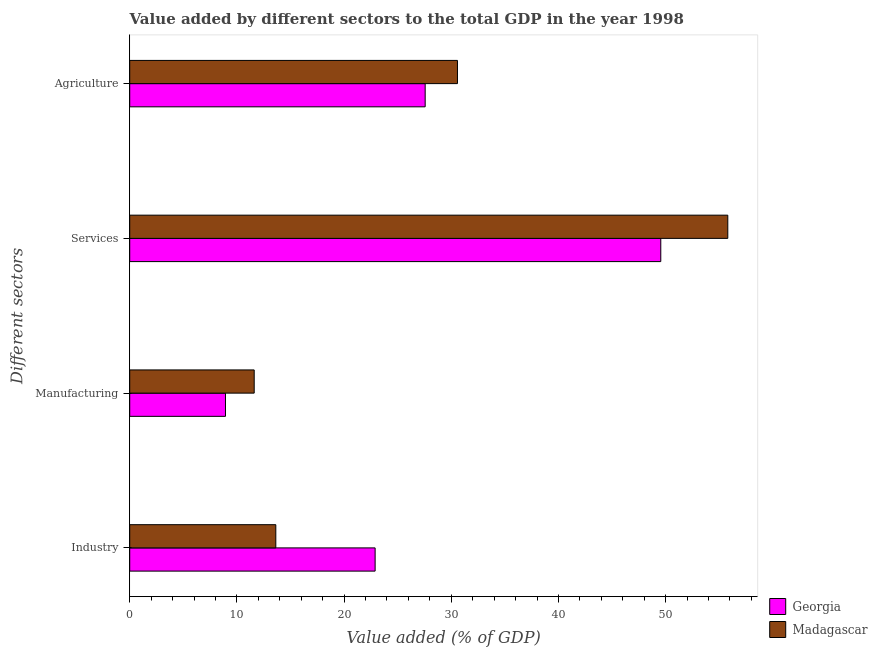How many groups of bars are there?
Offer a terse response. 4. How many bars are there on the 1st tick from the top?
Your response must be concise. 2. What is the label of the 1st group of bars from the top?
Ensure brevity in your answer.  Agriculture. What is the value added by agricultural sector in Georgia?
Offer a very short reply. 27.56. Across all countries, what is the maximum value added by industrial sector?
Make the answer very short. 22.89. Across all countries, what is the minimum value added by industrial sector?
Ensure brevity in your answer.  13.63. In which country was the value added by manufacturing sector maximum?
Your answer should be very brief. Madagascar. In which country was the value added by manufacturing sector minimum?
Provide a succinct answer. Georgia. What is the total value added by agricultural sector in the graph?
Make the answer very short. 58.14. What is the difference between the value added by services sector in Georgia and that in Madagascar?
Give a very brief answer. -6.25. What is the difference between the value added by agricultural sector in Madagascar and the value added by services sector in Georgia?
Your response must be concise. -18.97. What is the average value added by agricultural sector per country?
Provide a succinct answer. 29.07. What is the difference between the value added by services sector and value added by industrial sector in Madagascar?
Keep it short and to the point. 42.17. In how many countries, is the value added by industrial sector greater than 36 %?
Ensure brevity in your answer.  0. What is the ratio of the value added by manufacturing sector in Madagascar to that in Georgia?
Give a very brief answer. 1.3. What is the difference between the highest and the second highest value added by industrial sector?
Provide a succinct answer. 9.27. What is the difference between the highest and the lowest value added by services sector?
Ensure brevity in your answer.  6.25. What does the 1st bar from the top in Manufacturing represents?
Offer a terse response. Madagascar. What does the 2nd bar from the bottom in Services represents?
Keep it short and to the point. Madagascar. Is it the case that in every country, the sum of the value added by industrial sector and value added by manufacturing sector is greater than the value added by services sector?
Your answer should be compact. No. What is the difference between two consecutive major ticks on the X-axis?
Make the answer very short. 10. How many legend labels are there?
Your answer should be very brief. 2. What is the title of the graph?
Offer a terse response. Value added by different sectors to the total GDP in the year 1998. Does "Thailand" appear as one of the legend labels in the graph?
Your answer should be compact. No. What is the label or title of the X-axis?
Offer a very short reply. Value added (% of GDP). What is the label or title of the Y-axis?
Offer a terse response. Different sectors. What is the Value added (% of GDP) of Georgia in Industry?
Provide a short and direct response. 22.89. What is the Value added (% of GDP) of Madagascar in Industry?
Your answer should be compact. 13.63. What is the Value added (% of GDP) in Georgia in Manufacturing?
Give a very brief answer. 8.93. What is the Value added (% of GDP) of Madagascar in Manufacturing?
Offer a terse response. 11.61. What is the Value added (% of GDP) of Georgia in Services?
Give a very brief answer. 49.54. What is the Value added (% of GDP) of Madagascar in Services?
Offer a terse response. 55.8. What is the Value added (% of GDP) of Georgia in Agriculture?
Offer a very short reply. 27.56. What is the Value added (% of GDP) in Madagascar in Agriculture?
Give a very brief answer. 30.58. Across all Different sectors, what is the maximum Value added (% of GDP) in Georgia?
Your response must be concise. 49.54. Across all Different sectors, what is the maximum Value added (% of GDP) of Madagascar?
Keep it short and to the point. 55.8. Across all Different sectors, what is the minimum Value added (% of GDP) in Georgia?
Provide a short and direct response. 8.93. Across all Different sectors, what is the minimum Value added (% of GDP) of Madagascar?
Make the answer very short. 11.61. What is the total Value added (% of GDP) in Georgia in the graph?
Provide a short and direct response. 108.93. What is the total Value added (% of GDP) in Madagascar in the graph?
Provide a short and direct response. 111.61. What is the difference between the Value added (% of GDP) in Georgia in Industry and that in Manufacturing?
Keep it short and to the point. 13.96. What is the difference between the Value added (% of GDP) of Madagascar in Industry and that in Manufacturing?
Keep it short and to the point. 2.02. What is the difference between the Value added (% of GDP) in Georgia in Industry and that in Services?
Your response must be concise. -26.65. What is the difference between the Value added (% of GDP) in Madagascar in Industry and that in Services?
Provide a short and direct response. -42.17. What is the difference between the Value added (% of GDP) in Georgia in Industry and that in Agriculture?
Your answer should be compact. -4.67. What is the difference between the Value added (% of GDP) of Madagascar in Industry and that in Agriculture?
Your response must be concise. -16.95. What is the difference between the Value added (% of GDP) in Georgia in Manufacturing and that in Services?
Offer a very short reply. -40.61. What is the difference between the Value added (% of GDP) of Madagascar in Manufacturing and that in Services?
Your response must be concise. -44.18. What is the difference between the Value added (% of GDP) of Georgia in Manufacturing and that in Agriculture?
Offer a very short reply. -18.63. What is the difference between the Value added (% of GDP) of Madagascar in Manufacturing and that in Agriculture?
Offer a very short reply. -18.96. What is the difference between the Value added (% of GDP) in Georgia in Services and that in Agriculture?
Offer a terse response. 21.98. What is the difference between the Value added (% of GDP) in Madagascar in Services and that in Agriculture?
Offer a very short reply. 25.22. What is the difference between the Value added (% of GDP) in Georgia in Industry and the Value added (% of GDP) in Madagascar in Manufacturing?
Offer a terse response. 11.28. What is the difference between the Value added (% of GDP) in Georgia in Industry and the Value added (% of GDP) in Madagascar in Services?
Ensure brevity in your answer.  -32.9. What is the difference between the Value added (% of GDP) of Georgia in Industry and the Value added (% of GDP) of Madagascar in Agriculture?
Offer a terse response. -7.68. What is the difference between the Value added (% of GDP) of Georgia in Manufacturing and the Value added (% of GDP) of Madagascar in Services?
Provide a short and direct response. -46.86. What is the difference between the Value added (% of GDP) of Georgia in Manufacturing and the Value added (% of GDP) of Madagascar in Agriculture?
Offer a terse response. -21.64. What is the difference between the Value added (% of GDP) of Georgia in Services and the Value added (% of GDP) of Madagascar in Agriculture?
Provide a succinct answer. 18.97. What is the average Value added (% of GDP) in Georgia per Different sectors?
Ensure brevity in your answer.  27.23. What is the average Value added (% of GDP) in Madagascar per Different sectors?
Provide a succinct answer. 27.9. What is the difference between the Value added (% of GDP) in Georgia and Value added (% of GDP) in Madagascar in Industry?
Provide a short and direct response. 9.27. What is the difference between the Value added (% of GDP) in Georgia and Value added (% of GDP) in Madagascar in Manufacturing?
Provide a succinct answer. -2.68. What is the difference between the Value added (% of GDP) in Georgia and Value added (% of GDP) in Madagascar in Services?
Give a very brief answer. -6.25. What is the difference between the Value added (% of GDP) of Georgia and Value added (% of GDP) of Madagascar in Agriculture?
Make the answer very short. -3.01. What is the ratio of the Value added (% of GDP) in Georgia in Industry to that in Manufacturing?
Your answer should be compact. 2.56. What is the ratio of the Value added (% of GDP) of Madagascar in Industry to that in Manufacturing?
Your answer should be compact. 1.17. What is the ratio of the Value added (% of GDP) of Georgia in Industry to that in Services?
Give a very brief answer. 0.46. What is the ratio of the Value added (% of GDP) in Madagascar in Industry to that in Services?
Offer a very short reply. 0.24. What is the ratio of the Value added (% of GDP) in Georgia in Industry to that in Agriculture?
Ensure brevity in your answer.  0.83. What is the ratio of the Value added (% of GDP) in Madagascar in Industry to that in Agriculture?
Keep it short and to the point. 0.45. What is the ratio of the Value added (% of GDP) of Georgia in Manufacturing to that in Services?
Provide a succinct answer. 0.18. What is the ratio of the Value added (% of GDP) in Madagascar in Manufacturing to that in Services?
Provide a succinct answer. 0.21. What is the ratio of the Value added (% of GDP) of Georgia in Manufacturing to that in Agriculture?
Offer a terse response. 0.32. What is the ratio of the Value added (% of GDP) in Madagascar in Manufacturing to that in Agriculture?
Offer a terse response. 0.38. What is the ratio of the Value added (% of GDP) in Georgia in Services to that in Agriculture?
Provide a short and direct response. 1.8. What is the ratio of the Value added (% of GDP) of Madagascar in Services to that in Agriculture?
Provide a short and direct response. 1.82. What is the difference between the highest and the second highest Value added (% of GDP) of Georgia?
Your answer should be compact. 21.98. What is the difference between the highest and the second highest Value added (% of GDP) of Madagascar?
Your answer should be compact. 25.22. What is the difference between the highest and the lowest Value added (% of GDP) in Georgia?
Give a very brief answer. 40.61. What is the difference between the highest and the lowest Value added (% of GDP) of Madagascar?
Your answer should be very brief. 44.18. 